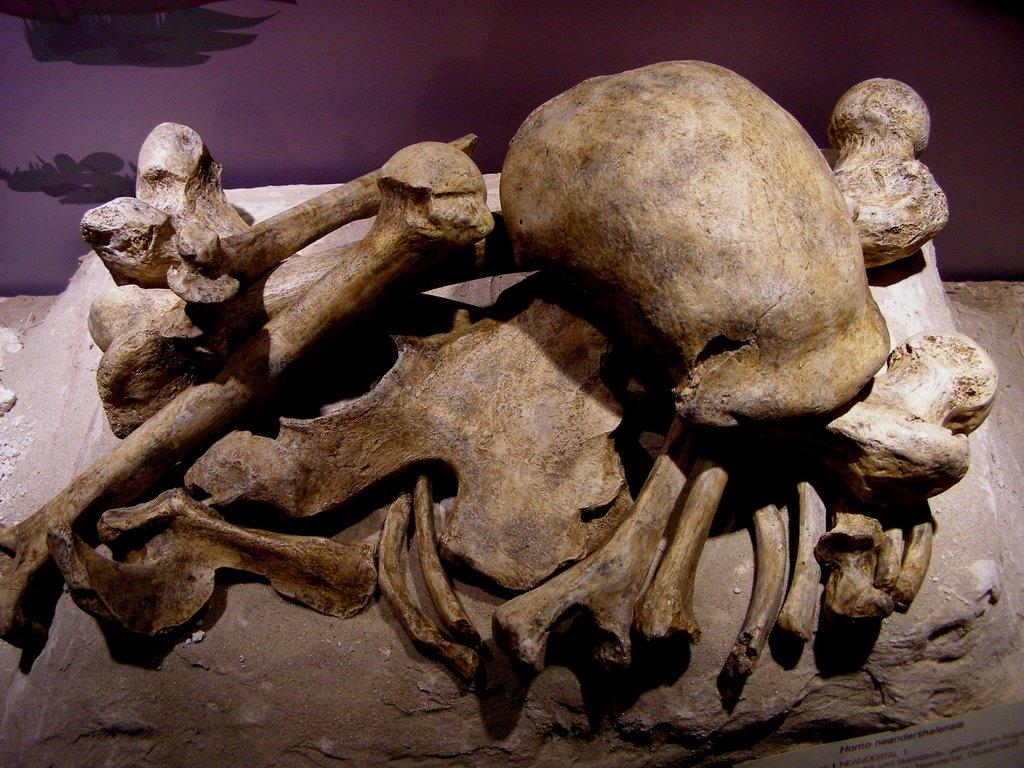What can be seen on the rock in the image? There are fossils on a rock in the image. What type of natural formation is the rock? The provided facts do not specify the type of rock. Can you describe the fossils in more detail? The provided facts do not specify the details of the fossils. What color is the doctor's bead in the image? There is no doctor or bead present in the image; it only features fossils on a rock. 